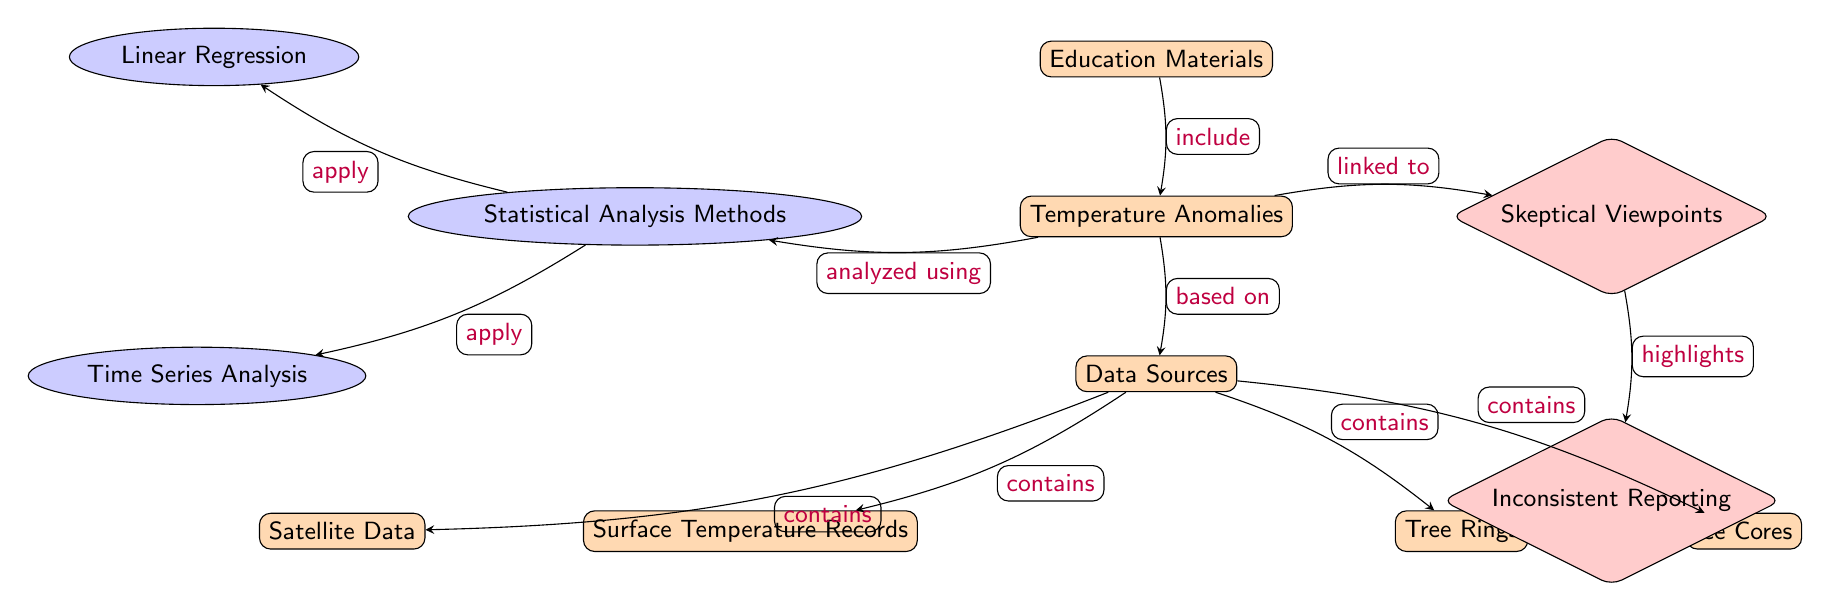What does the node "Temperature Anomalies" represent? The node "Temperature Anomalies" represents a key concept in the diagram, illustrating deviations in temperature over time, specifically in the context of climate data analysis.
Answer: Temperature Anomalies How many data source nodes are present in the diagram? The diagram includes four data source nodes: Surface Temperature Records, Satellite Data, Tree Rings, and Ice Cores. Counting these nodes provides the answer.
Answer: 4 Which statistical analysis method is applied to analyze temperature anomalies? The node for statistical analysis methods points to two specific approaches: Linear Regression and Time Series Analysis. Based on the connection labels, any method linked to this node can be considered.
Answer: Statistical Analysis Methods What controversy is linked to temperature anomalies? The "Skeptical Viewpoints" node is linked to "Temperature Anomalies," indicating a relationship between public skepticism and the interpretation or reporting of temperature changes.
Answer: Skeptical Viewpoints What does the "Inconsistent Reporting" node highlight? The connection shows that it is highlighted as a concern arising from the node "Skeptical Viewpoints," indicating that the way temperature anomalies are reported may lead to mistrust or misunderstandings.
Answer: Inconsistent Reporting Which data source is situated below "Data Sources"? The "Tree Rings" node is positioned below "Data Sources," signifying a hierarchy where tree rings are one of the sources being discussed in relation to temperature anomalies.
Answer: Tree Rings What methods are used alongside linear regression? According to the nodes linked to "Statistical Analysis Methods," both Linear Regression and Time Series Analysis are applied methods. This demonstrates the analytical tools utilized for assessing the temperature anomalies.
Answer: Time Series Analysis How does "Education Materials" relate to "Temperature Anomalies"? The "Education Materials" node is positioned above "Temperature Anomalies," showing that educational resources include information or illustrations about temperature anomalies, which is directed by the arrow indicating inclusion.
Answer: Include Which node shows the relationship with "Temperature Anomalies"? The connecting node "Data Sources" shows that "Temperature Anomalies" are based on various data sources, indicating the foundational support for analyzing these anomalies.
Answer: Data Sources 